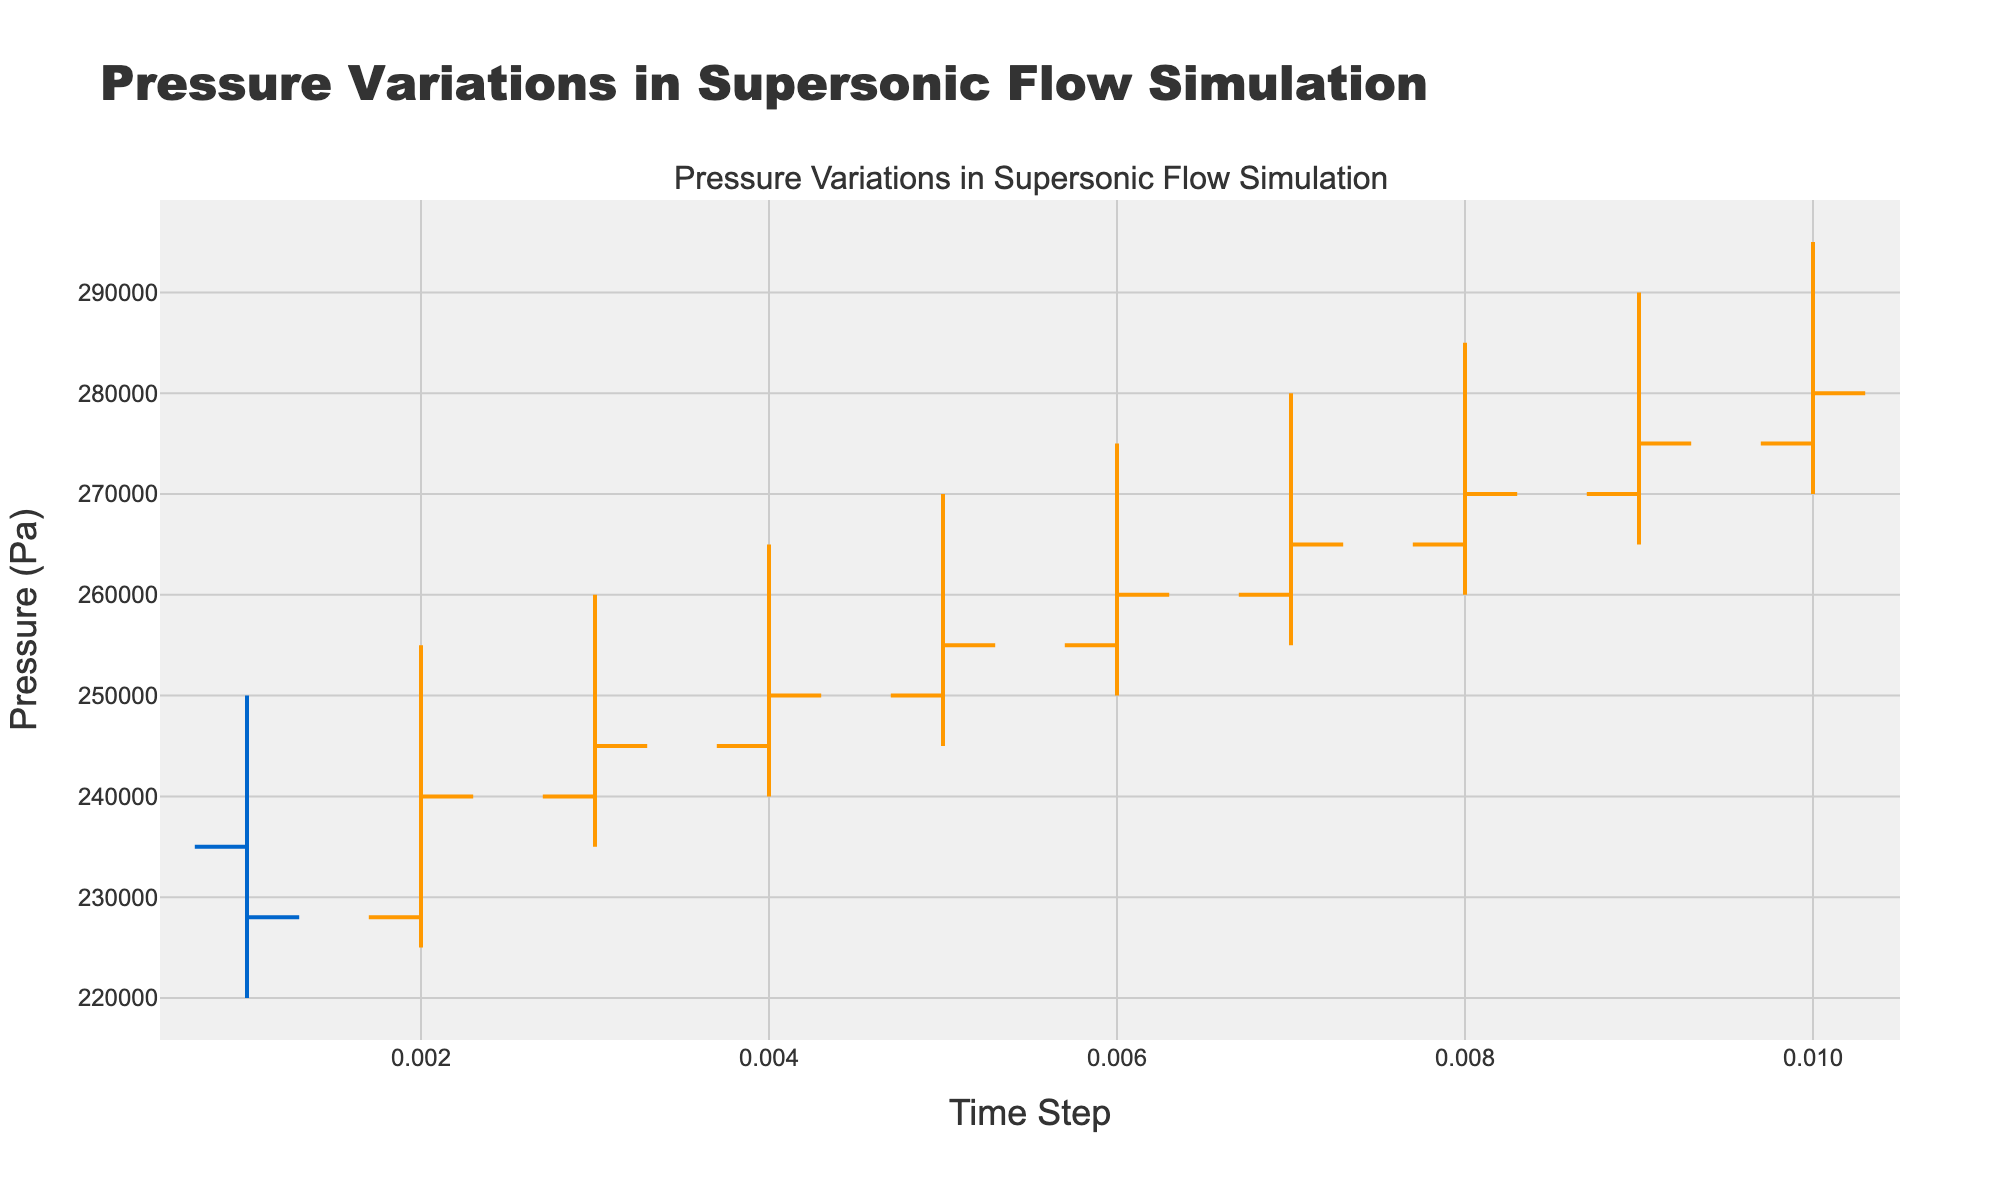Which color represents increasing pressure values? The figure's legend indicates the line color for increasing pressure values.
Answer: Orange What is the title of the figure? The title is located at the top of the figure.
Answer: "Pressure Variations in Supersonic Flow Simulation" How many time steps are displayed in the figure? Count the number of distinct time steps on the x-axis.
Answer: 10 What is the difference between the highest and lowest pressure values at the second time step? At time step 0.002, the highest pressure is 255,000 Pa and the lowest is 225,000 Pa. The difference is 255,000 - 225,000.
Answer: 30,000 Pa Which time step has the highest closing pressure value? Look at the closing pressure values across all time steps and identify the highest one.
Answer: 0.010 During which time step does the closing pressure exceed the opening pressure by the largest amount? Calculate the difference between the closing and opening pressures for each time step and identify the maximal value. At time step 0.002, the difference is 240,000 - 228,000 = 12,000 Pa. This is the largest.
Answer: 0.002 What is the average high pressure value throughout the shown time steps? Sum the high pressure values for all time steps and divide by the number of time steps. (250,000 + 255,000 + 260,000 + 265,000 + 270,000 + 275,000 + 280,000 + 285,000 + 290,000 + 295,000)/10
Answer: 272,500 Pa Which time step shows a decrease in closing pressure relative to the opening pressure? Compare the opening and closing pressures for each time step to observe any decreases. At time step 0.001, closing pressure (228,000 Pa) is less than opening pressure (235,000 Pa).
Answer: 0.001 What is the trend of the high pressure value over time? Observe the progression of high pressure values from the first to the last time step.
Answer: Increasing trend What type of lines/colors are used to indicate decreasing pressure values? The figure's legend indicates the line color for decreasing pressure values.
Answer: Blue 